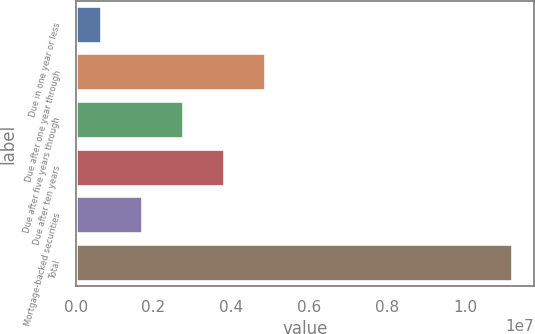<chart> <loc_0><loc_0><loc_500><loc_500><bar_chart><fcel>Due in one year or less<fcel>Due after one year through<fcel>Due after five years through<fcel>Due after ten years<fcel>Mortgage-backed securities<fcel>Total<nl><fcel>671995<fcel>4.89038e+06<fcel>2.78119e+06<fcel>3.83578e+06<fcel>1.72659e+06<fcel>1.1218e+07<nl></chart> 